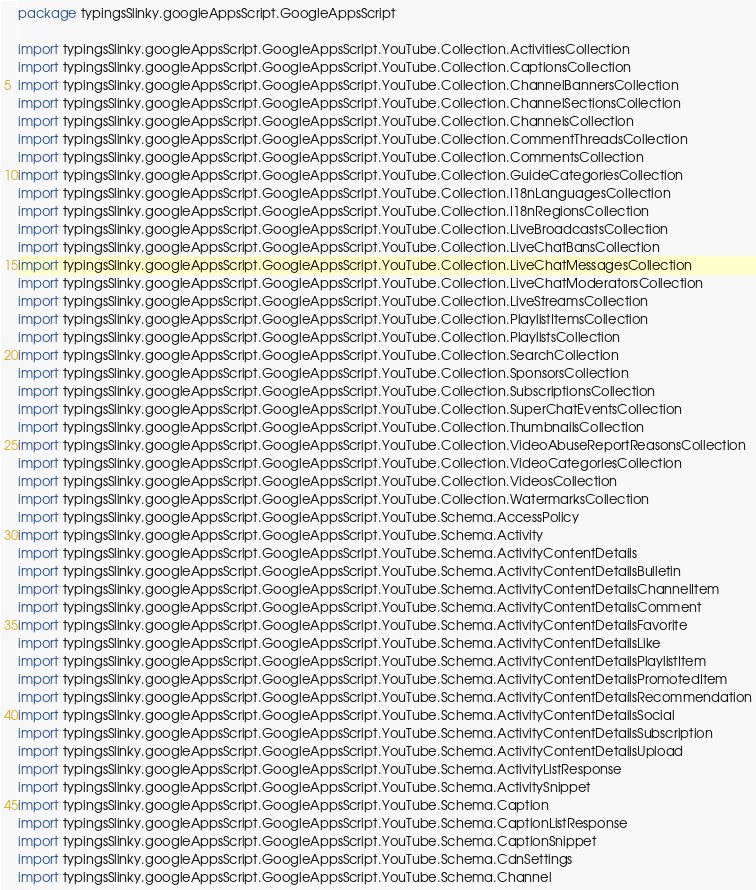<code> <loc_0><loc_0><loc_500><loc_500><_Scala_>package typingsSlinky.googleAppsScript.GoogleAppsScript

import typingsSlinky.googleAppsScript.GoogleAppsScript.YouTube.Collection.ActivitiesCollection
import typingsSlinky.googleAppsScript.GoogleAppsScript.YouTube.Collection.CaptionsCollection
import typingsSlinky.googleAppsScript.GoogleAppsScript.YouTube.Collection.ChannelBannersCollection
import typingsSlinky.googleAppsScript.GoogleAppsScript.YouTube.Collection.ChannelSectionsCollection
import typingsSlinky.googleAppsScript.GoogleAppsScript.YouTube.Collection.ChannelsCollection
import typingsSlinky.googleAppsScript.GoogleAppsScript.YouTube.Collection.CommentThreadsCollection
import typingsSlinky.googleAppsScript.GoogleAppsScript.YouTube.Collection.CommentsCollection
import typingsSlinky.googleAppsScript.GoogleAppsScript.YouTube.Collection.GuideCategoriesCollection
import typingsSlinky.googleAppsScript.GoogleAppsScript.YouTube.Collection.I18nLanguagesCollection
import typingsSlinky.googleAppsScript.GoogleAppsScript.YouTube.Collection.I18nRegionsCollection
import typingsSlinky.googleAppsScript.GoogleAppsScript.YouTube.Collection.LiveBroadcastsCollection
import typingsSlinky.googleAppsScript.GoogleAppsScript.YouTube.Collection.LiveChatBansCollection
import typingsSlinky.googleAppsScript.GoogleAppsScript.YouTube.Collection.LiveChatMessagesCollection
import typingsSlinky.googleAppsScript.GoogleAppsScript.YouTube.Collection.LiveChatModeratorsCollection
import typingsSlinky.googleAppsScript.GoogleAppsScript.YouTube.Collection.LiveStreamsCollection
import typingsSlinky.googleAppsScript.GoogleAppsScript.YouTube.Collection.PlaylistItemsCollection
import typingsSlinky.googleAppsScript.GoogleAppsScript.YouTube.Collection.PlaylistsCollection
import typingsSlinky.googleAppsScript.GoogleAppsScript.YouTube.Collection.SearchCollection
import typingsSlinky.googleAppsScript.GoogleAppsScript.YouTube.Collection.SponsorsCollection
import typingsSlinky.googleAppsScript.GoogleAppsScript.YouTube.Collection.SubscriptionsCollection
import typingsSlinky.googleAppsScript.GoogleAppsScript.YouTube.Collection.SuperChatEventsCollection
import typingsSlinky.googleAppsScript.GoogleAppsScript.YouTube.Collection.ThumbnailsCollection
import typingsSlinky.googleAppsScript.GoogleAppsScript.YouTube.Collection.VideoAbuseReportReasonsCollection
import typingsSlinky.googleAppsScript.GoogleAppsScript.YouTube.Collection.VideoCategoriesCollection
import typingsSlinky.googleAppsScript.GoogleAppsScript.YouTube.Collection.VideosCollection
import typingsSlinky.googleAppsScript.GoogleAppsScript.YouTube.Collection.WatermarksCollection
import typingsSlinky.googleAppsScript.GoogleAppsScript.YouTube.Schema.AccessPolicy
import typingsSlinky.googleAppsScript.GoogleAppsScript.YouTube.Schema.Activity
import typingsSlinky.googleAppsScript.GoogleAppsScript.YouTube.Schema.ActivityContentDetails
import typingsSlinky.googleAppsScript.GoogleAppsScript.YouTube.Schema.ActivityContentDetailsBulletin
import typingsSlinky.googleAppsScript.GoogleAppsScript.YouTube.Schema.ActivityContentDetailsChannelItem
import typingsSlinky.googleAppsScript.GoogleAppsScript.YouTube.Schema.ActivityContentDetailsComment
import typingsSlinky.googleAppsScript.GoogleAppsScript.YouTube.Schema.ActivityContentDetailsFavorite
import typingsSlinky.googleAppsScript.GoogleAppsScript.YouTube.Schema.ActivityContentDetailsLike
import typingsSlinky.googleAppsScript.GoogleAppsScript.YouTube.Schema.ActivityContentDetailsPlaylistItem
import typingsSlinky.googleAppsScript.GoogleAppsScript.YouTube.Schema.ActivityContentDetailsPromotedItem
import typingsSlinky.googleAppsScript.GoogleAppsScript.YouTube.Schema.ActivityContentDetailsRecommendation
import typingsSlinky.googleAppsScript.GoogleAppsScript.YouTube.Schema.ActivityContentDetailsSocial
import typingsSlinky.googleAppsScript.GoogleAppsScript.YouTube.Schema.ActivityContentDetailsSubscription
import typingsSlinky.googleAppsScript.GoogleAppsScript.YouTube.Schema.ActivityContentDetailsUpload
import typingsSlinky.googleAppsScript.GoogleAppsScript.YouTube.Schema.ActivityListResponse
import typingsSlinky.googleAppsScript.GoogleAppsScript.YouTube.Schema.ActivitySnippet
import typingsSlinky.googleAppsScript.GoogleAppsScript.YouTube.Schema.Caption
import typingsSlinky.googleAppsScript.GoogleAppsScript.YouTube.Schema.CaptionListResponse
import typingsSlinky.googleAppsScript.GoogleAppsScript.YouTube.Schema.CaptionSnippet
import typingsSlinky.googleAppsScript.GoogleAppsScript.YouTube.Schema.CdnSettings
import typingsSlinky.googleAppsScript.GoogleAppsScript.YouTube.Schema.Channel</code> 